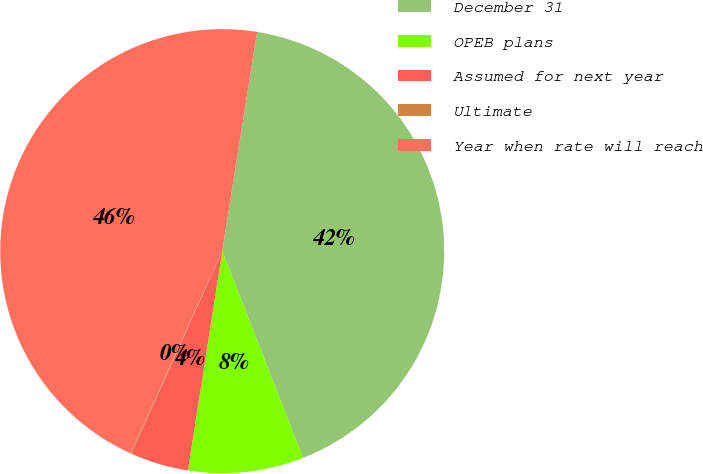<chart> <loc_0><loc_0><loc_500><loc_500><pie_chart><fcel>December 31<fcel>OPEB plans<fcel>Assumed for next year<fcel>Ultimate<fcel>Year when rate will reach<nl><fcel>41.57%<fcel>8.39%<fcel>4.24%<fcel>0.08%<fcel>45.72%<nl></chart> 